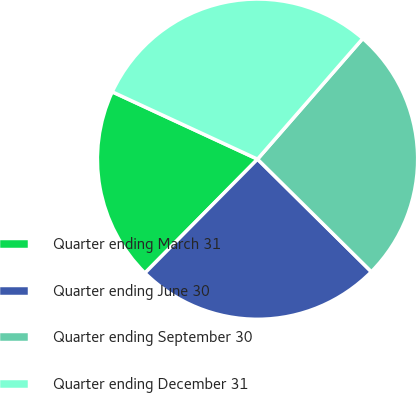<chart> <loc_0><loc_0><loc_500><loc_500><pie_chart><fcel>Quarter ending March 31<fcel>Quarter ending June 30<fcel>Quarter ending September 30<fcel>Quarter ending December 31<nl><fcel>19.5%<fcel>25.0%<fcel>26.0%<fcel>29.51%<nl></chart> 